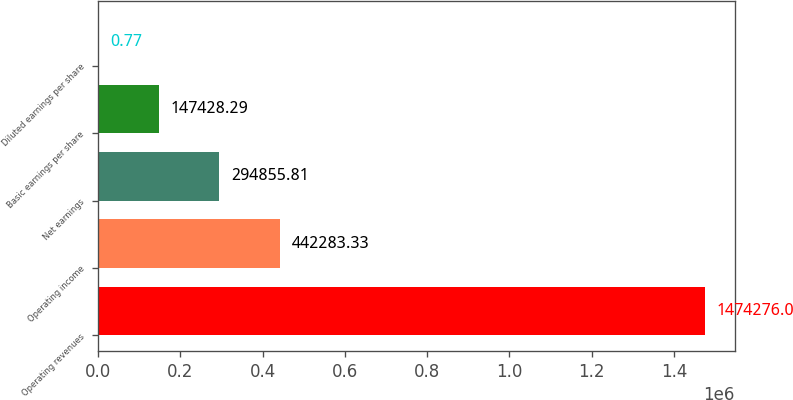<chart> <loc_0><loc_0><loc_500><loc_500><bar_chart><fcel>Operating revenues<fcel>Operating income<fcel>Net earnings<fcel>Basic earnings per share<fcel>Diluted earnings per share<nl><fcel>1.47428e+06<fcel>442283<fcel>294856<fcel>147428<fcel>0.77<nl></chart> 